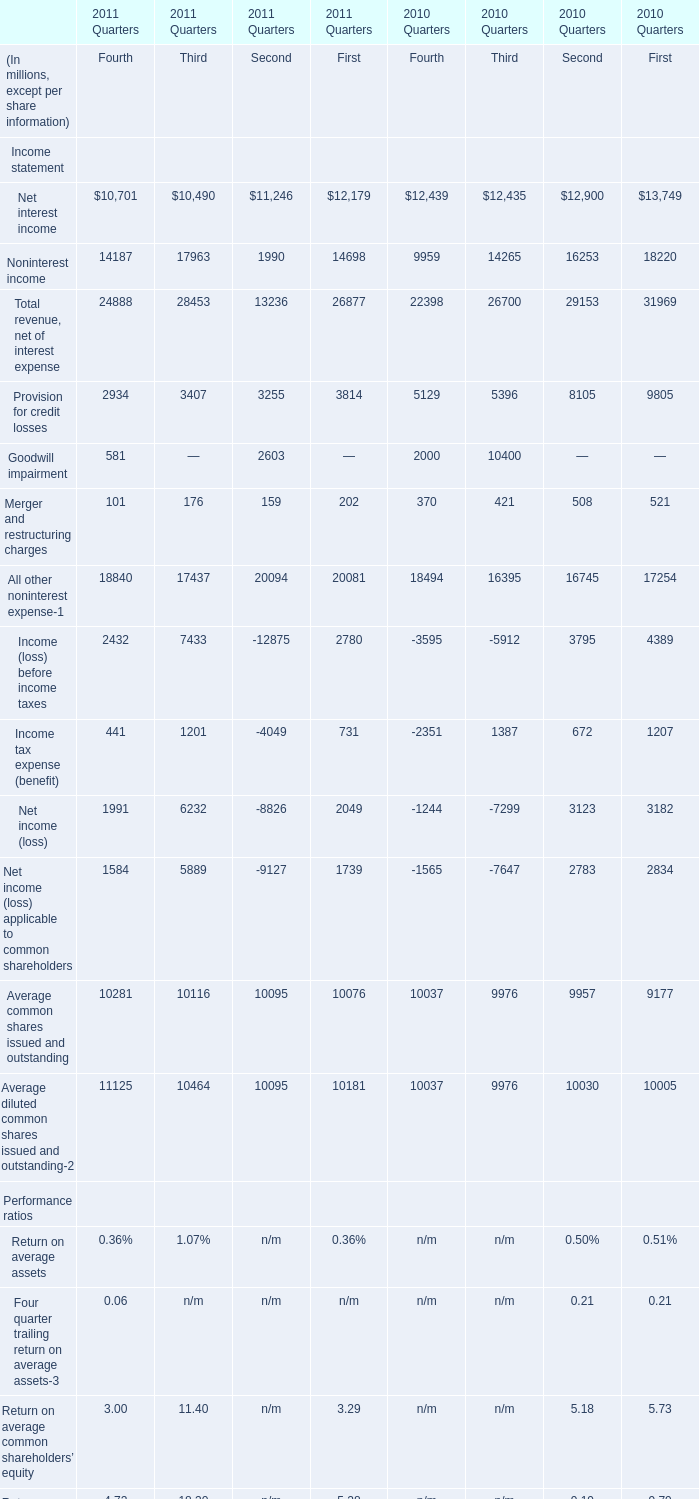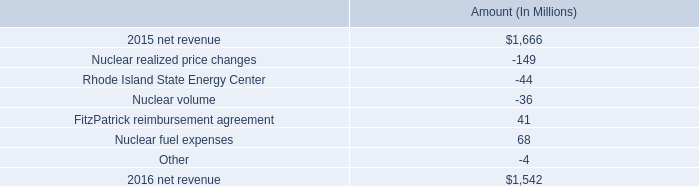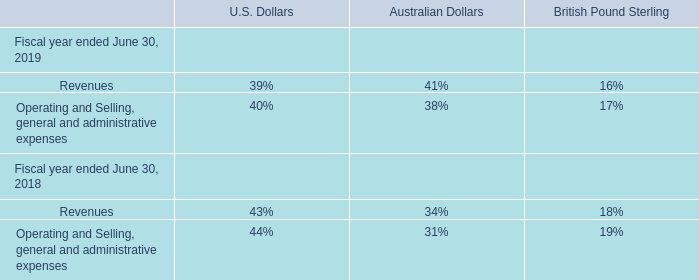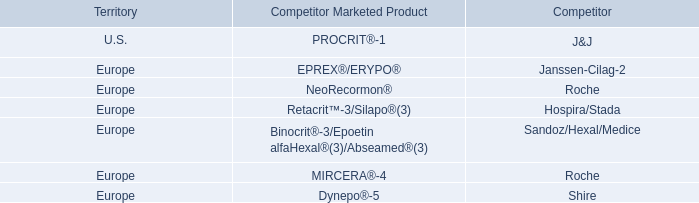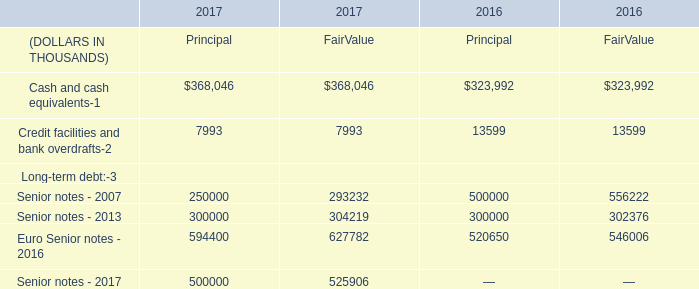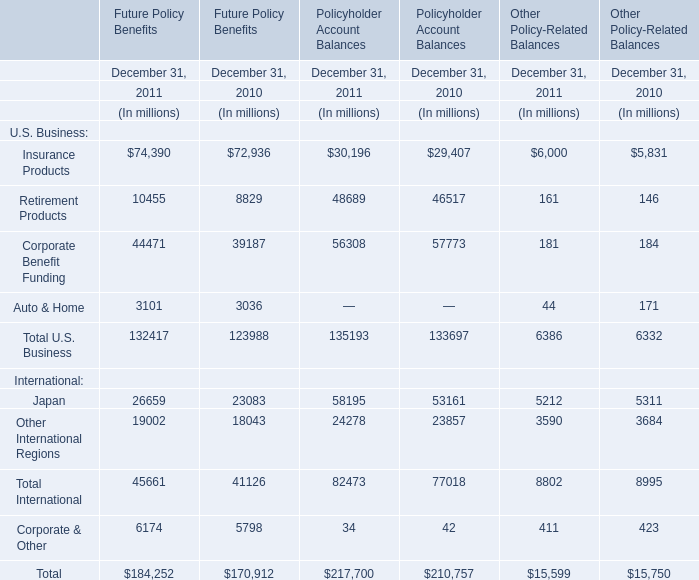What is the average amount of All other noninterest expense of 2010 Quarters Second, and Credit facilities and bank overdrafts of 2016 FairValue ? 
Computations: ((16745.0 + 13599.0) / 2)
Answer: 15172.0. 